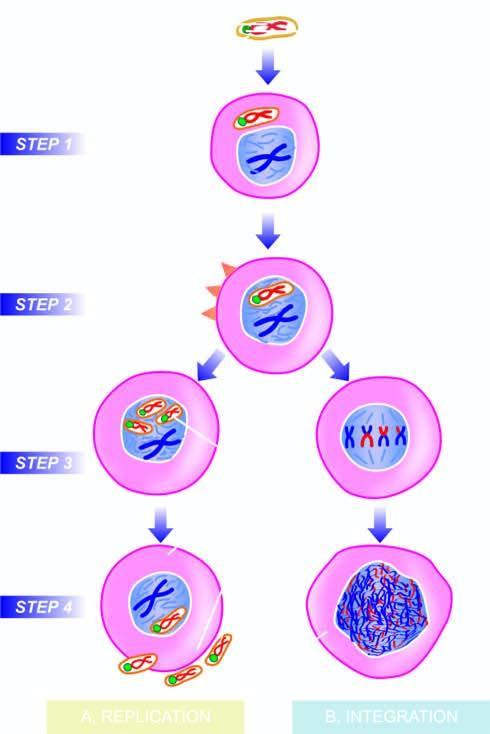re the new virions assembled in the cell nucleus?
Answer the question using a single word or phrase. Yes 